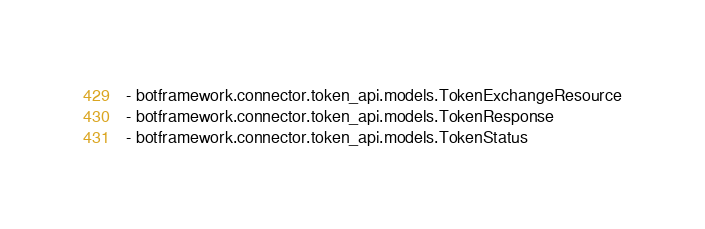Convert code to text. <code><loc_0><loc_0><loc_500><loc_500><_YAML_>- botframework.connector.token_api.models.TokenExchangeResource
- botframework.connector.token_api.models.TokenResponse
- botframework.connector.token_api.models.TokenStatus
</code> 